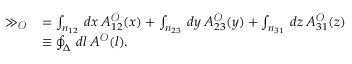<formula> <loc_0><loc_0><loc_500><loc_500>\begin{array} { r l } { \gg _ { \ m a t h s c r { O } } } & { = \int _ { n _ { 1 2 } } \, d x \, { A } _ { 1 2 } ^ { \ m a t h s c r { O } } ( x ) + \int _ { n _ { 2 3 } } \, d y \, { A } _ { 2 3 } ^ { \ m a t h s c r { O } } ( y ) + \int _ { n _ { 3 1 } } \, d z \, { A } _ { 3 1 } ^ { \ m a t h s c r { O } } ( z ) } \\ & { \equiv \oint _ { \Delta } \, d l \, { A } ^ { \ m a t h s c r { O } } ( l ) . } \end{array}</formula> 